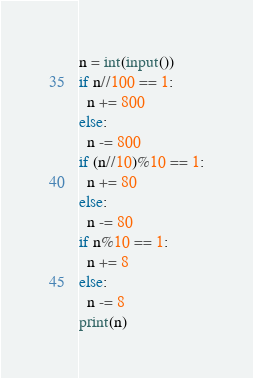Convert code to text. <code><loc_0><loc_0><loc_500><loc_500><_Python_>n = int(input())
if n//100 == 1:
  n += 800
else:
  n -= 800
if (n//10)%10 == 1:
  n += 80
else:
  n -= 80
if n%10 == 1:
  n += 8
else:
  n -= 8
print(n)</code> 